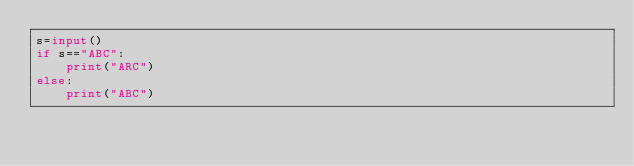Convert code to text. <code><loc_0><loc_0><loc_500><loc_500><_Python_>s=input()
if s=="ABC":
	print("ARC")
else:
	print("ABC")</code> 